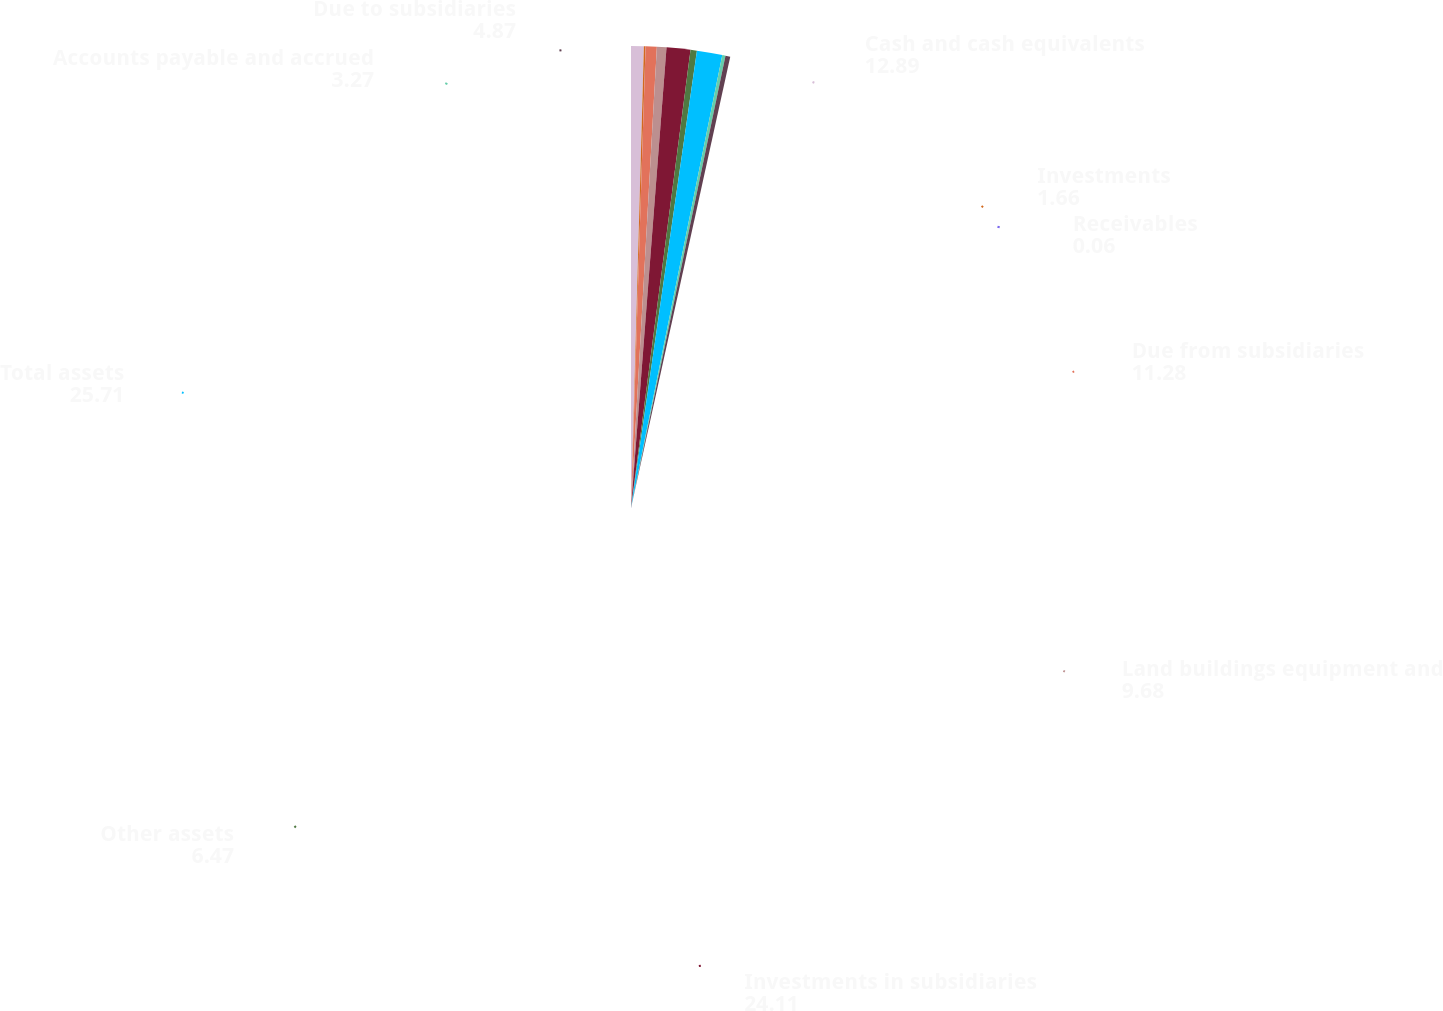Convert chart. <chart><loc_0><loc_0><loc_500><loc_500><pie_chart><fcel>Cash and cash equivalents<fcel>Investments<fcel>Receivables<fcel>Due from subsidiaries<fcel>Land buildings equipment and<fcel>Investments in subsidiaries<fcel>Other assets<fcel>Total assets<fcel>Accounts payable and accrued<fcel>Due to subsidiaries<nl><fcel>12.89%<fcel>1.66%<fcel>0.06%<fcel>11.28%<fcel>9.68%<fcel>24.11%<fcel>6.47%<fcel>25.71%<fcel>3.27%<fcel>4.87%<nl></chart> 